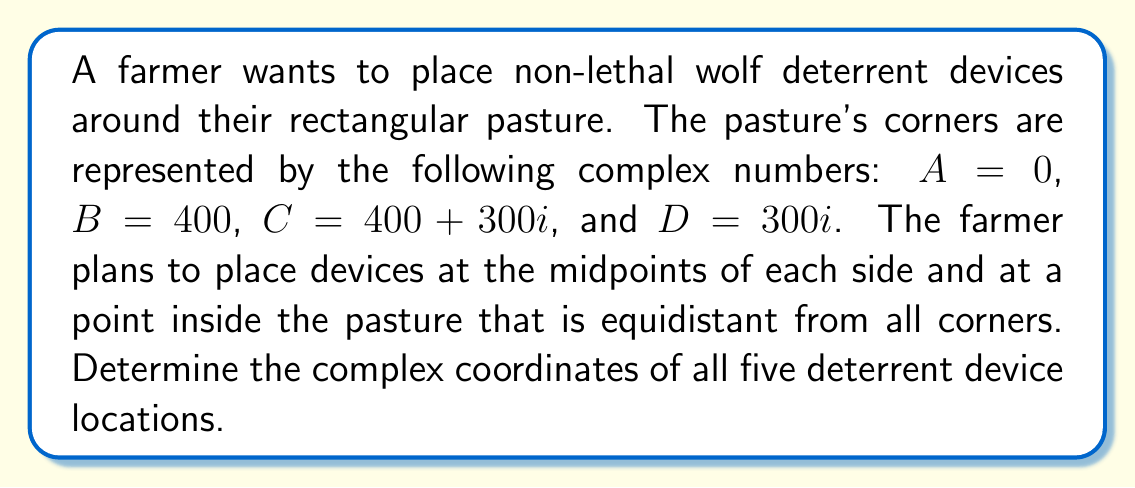Solve this math problem. Let's approach this step-by-step:

1) First, let's find the midpoints of each side:

   Side AB: $\frac{A + B}{2} = \frac{0 + 400}{2} = 200$
   Side BC: $\frac{B + C}{2} = \frac{400 + (400 + 300i)}{2} = 400 + 150i$
   Side CD: $\frac{C + D}{2} = \frac{(400 + 300i) + 300i}{2} = 200 + 300i$
   Side DA: $\frac{D + A}{2} = \frac{300i + 0}{2} = 150i$

2) Now, for the point inside the pasture that is equidistant from all corners, we need to find the centroid of the rectangle. The centroid of a rectangle is located at the intersection of its diagonals, which is the average of all corner coordinates:

   $Centroid = \frac{A + B + C + D}{4} = \frac{0 + 400 + (400 + 300i) + 300i}{4} = \frac{800 + 600i}{4} = 200 + 150i$

3) Therefore, the five deterrent device locations are:
   - $200$ (midpoint of AB)
   - $400 + 150i$ (midpoint of BC)
   - $200 + 300i$ (midpoint of CD)
   - $150i$ (midpoint of DA)
   - $200 + 150i$ (centroid)

[asy]
unitsize(0.01cm);
pair A = (0,0), B = (400,0), C = (400,300), D = (0,300);
draw(A--B--C--D--cycle);
dot("A",A,SW);
dot("B",B,SE);
dot("C",C,NE);
dot("D",D,NW);
dot("",200,0,S);
dot("",400,150,E);
dot("",200,300,N);
dot("",0,150,W);
dot("",200,150);
label("200",(200,0),S);
label("400+150i",(400,150),E);
label("200+300i",(200,300),N);
label("150i",(0,150),W);
label("200+150i",(200,150),SE);
[/asy]
Answer: The complex coordinates of the five deterrent device locations are: $200$, $400 + 150i$, $200 + 300i$, $150i$, and $200 + 150i$. 